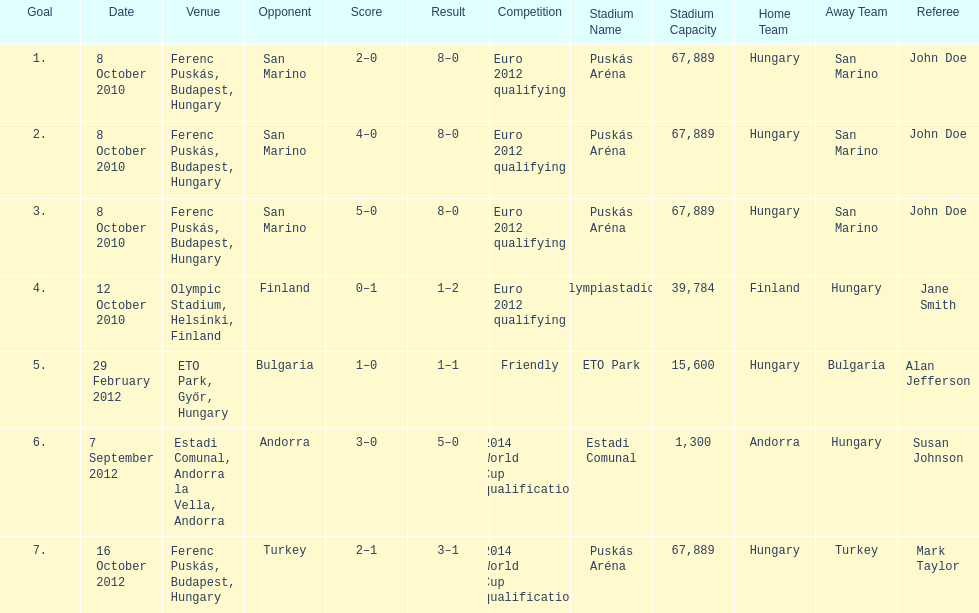How many consecutive games were goals were against san marino? 3. 